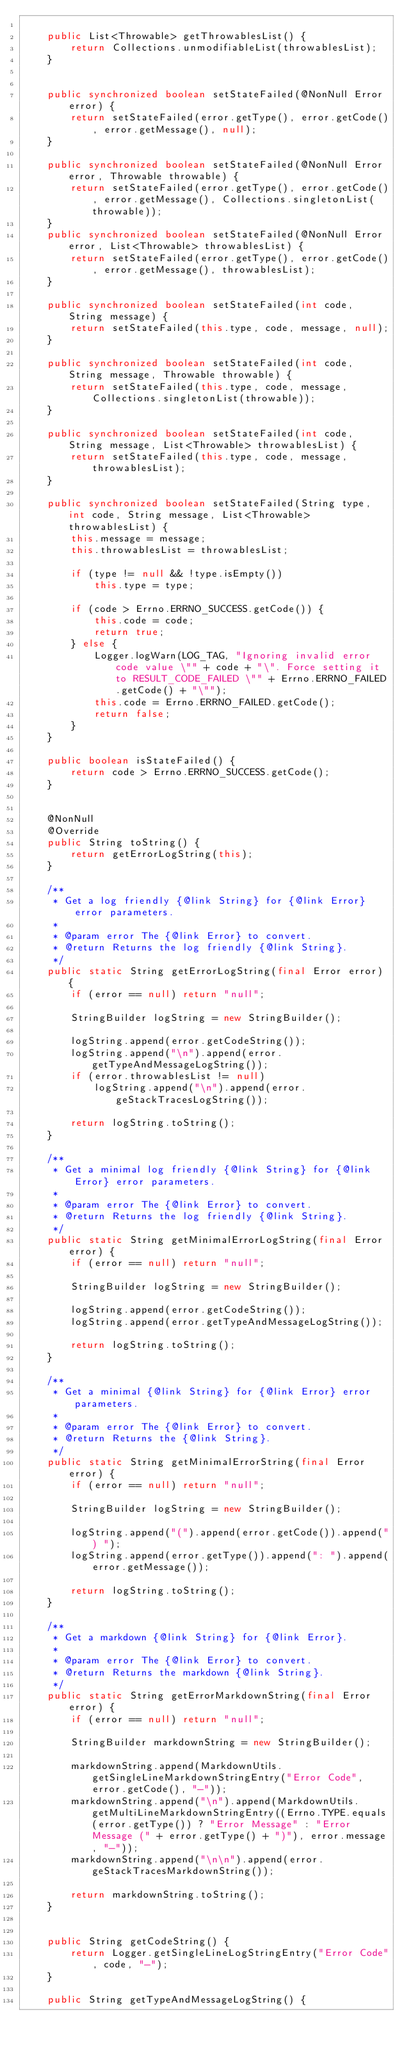Convert code to text. <code><loc_0><loc_0><loc_500><loc_500><_Java_>
    public List<Throwable> getThrowablesList() {
        return Collections.unmodifiableList(throwablesList);
    }


    public synchronized boolean setStateFailed(@NonNull Error error) {
        return setStateFailed(error.getType(), error.getCode(), error.getMessage(), null);
    }

    public synchronized boolean setStateFailed(@NonNull Error error, Throwable throwable) {
        return setStateFailed(error.getType(), error.getCode(), error.getMessage(), Collections.singletonList(throwable));
    }
    public synchronized boolean setStateFailed(@NonNull Error error, List<Throwable> throwablesList) {
        return setStateFailed(error.getType(), error.getCode(), error.getMessage(), throwablesList);
    }

    public synchronized boolean setStateFailed(int code, String message) {
        return setStateFailed(this.type, code, message, null);
    }

    public synchronized boolean setStateFailed(int code, String message, Throwable throwable) {
        return setStateFailed(this.type, code, message, Collections.singletonList(throwable));
    }

    public synchronized boolean setStateFailed(int code, String message, List<Throwable> throwablesList) {
        return setStateFailed(this.type, code, message, throwablesList);
    }

    public synchronized boolean setStateFailed(String type, int code, String message, List<Throwable> throwablesList) {
        this.message = message;
        this.throwablesList = throwablesList;

        if (type != null && !type.isEmpty())
            this.type = type;

        if (code > Errno.ERRNO_SUCCESS.getCode()) {
            this.code = code;
            return true;
        } else {
            Logger.logWarn(LOG_TAG, "Ignoring invalid error code value \"" + code + "\". Force setting it to RESULT_CODE_FAILED \"" + Errno.ERRNO_FAILED.getCode() + "\"");
            this.code = Errno.ERRNO_FAILED.getCode();
            return false;
        }
    }

    public boolean isStateFailed() {
        return code > Errno.ERRNO_SUCCESS.getCode();
    }


    @NonNull
    @Override
    public String toString() {
        return getErrorLogString(this);
    }

    /**
     * Get a log friendly {@link String} for {@link Error} error parameters.
     *
     * @param error The {@link Error} to convert.
     * @return Returns the log friendly {@link String}.
     */
    public static String getErrorLogString(final Error error) {
        if (error == null) return "null";

        StringBuilder logString = new StringBuilder();

        logString.append(error.getCodeString());
        logString.append("\n").append(error.getTypeAndMessageLogString());
        if (error.throwablesList != null)
            logString.append("\n").append(error.geStackTracesLogString());

        return logString.toString();
    }

    /**
     * Get a minimal log friendly {@link String} for {@link Error} error parameters.
     *
     * @param error The {@link Error} to convert.
     * @return Returns the log friendly {@link String}.
     */
    public static String getMinimalErrorLogString(final Error error) {
        if (error == null) return "null";

        StringBuilder logString = new StringBuilder();

        logString.append(error.getCodeString());
        logString.append(error.getTypeAndMessageLogString());

        return logString.toString();
    }

    /**
     * Get a minimal {@link String} for {@link Error} error parameters.
     *
     * @param error The {@link Error} to convert.
     * @return Returns the {@link String}.
     */
    public static String getMinimalErrorString(final Error error) {
        if (error == null) return "null";

        StringBuilder logString = new StringBuilder();

        logString.append("(").append(error.getCode()).append(") ");
        logString.append(error.getType()).append(": ").append(error.getMessage());

        return logString.toString();
    }

    /**
     * Get a markdown {@link String} for {@link Error}.
     *
     * @param error The {@link Error} to convert.
     * @return Returns the markdown {@link String}.
     */
    public static String getErrorMarkdownString(final Error error) {
        if (error == null) return "null";

        StringBuilder markdownString = new StringBuilder();

        markdownString.append(MarkdownUtils.getSingleLineMarkdownStringEntry("Error Code", error.getCode(), "-"));
        markdownString.append("\n").append(MarkdownUtils.getMultiLineMarkdownStringEntry((Errno.TYPE.equals(error.getType()) ? "Error Message" : "Error Message (" + error.getType() + ")"), error.message, "-"));
        markdownString.append("\n\n").append(error.geStackTracesMarkdownString());

        return markdownString.toString();
    }


    public String getCodeString() {
        return Logger.getSingleLineLogStringEntry("Error Code", code, "-");
    }

    public String getTypeAndMessageLogString() {</code> 